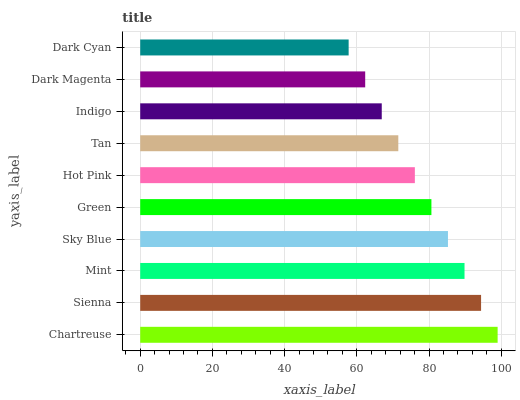Is Dark Cyan the minimum?
Answer yes or no. Yes. Is Chartreuse the maximum?
Answer yes or no. Yes. Is Sienna the minimum?
Answer yes or no. No. Is Sienna the maximum?
Answer yes or no. No. Is Chartreuse greater than Sienna?
Answer yes or no. Yes. Is Sienna less than Chartreuse?
Answer yes or no. Yes. Is Sienna greater than Chartreuse?
Answer yes or no. No. Is Chartreuse less than Sienna?
Answer yes or no. No. Is Green the high median?
Answer yes or no. Yes. Is Hot Pink the low median?
Answer yes or no. Yes. Is Indigo the high median?
Answer yes or no. No. Is Dark Magenta the low median?
Answer yes or no. No. 